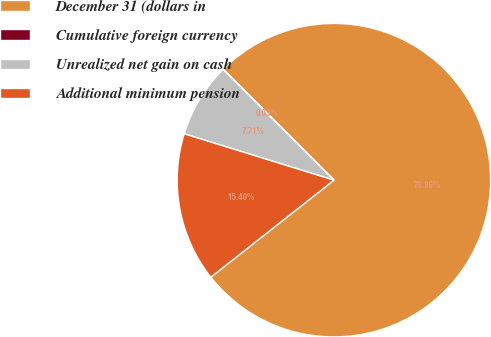Convert chart to OTSL. <chart><loc_0><loc_0><loc_500><loc_500><pie_chart><fcel>December 31 (dollars in<fcel>Cumulative foreign currency<fcel>Unrealized net gain on cash<fcel>Additional minimum pension<nl><fcel>76.86%<fcel>0.03%<fcel>7.71%<fcel>15.4%<nl></chart> 